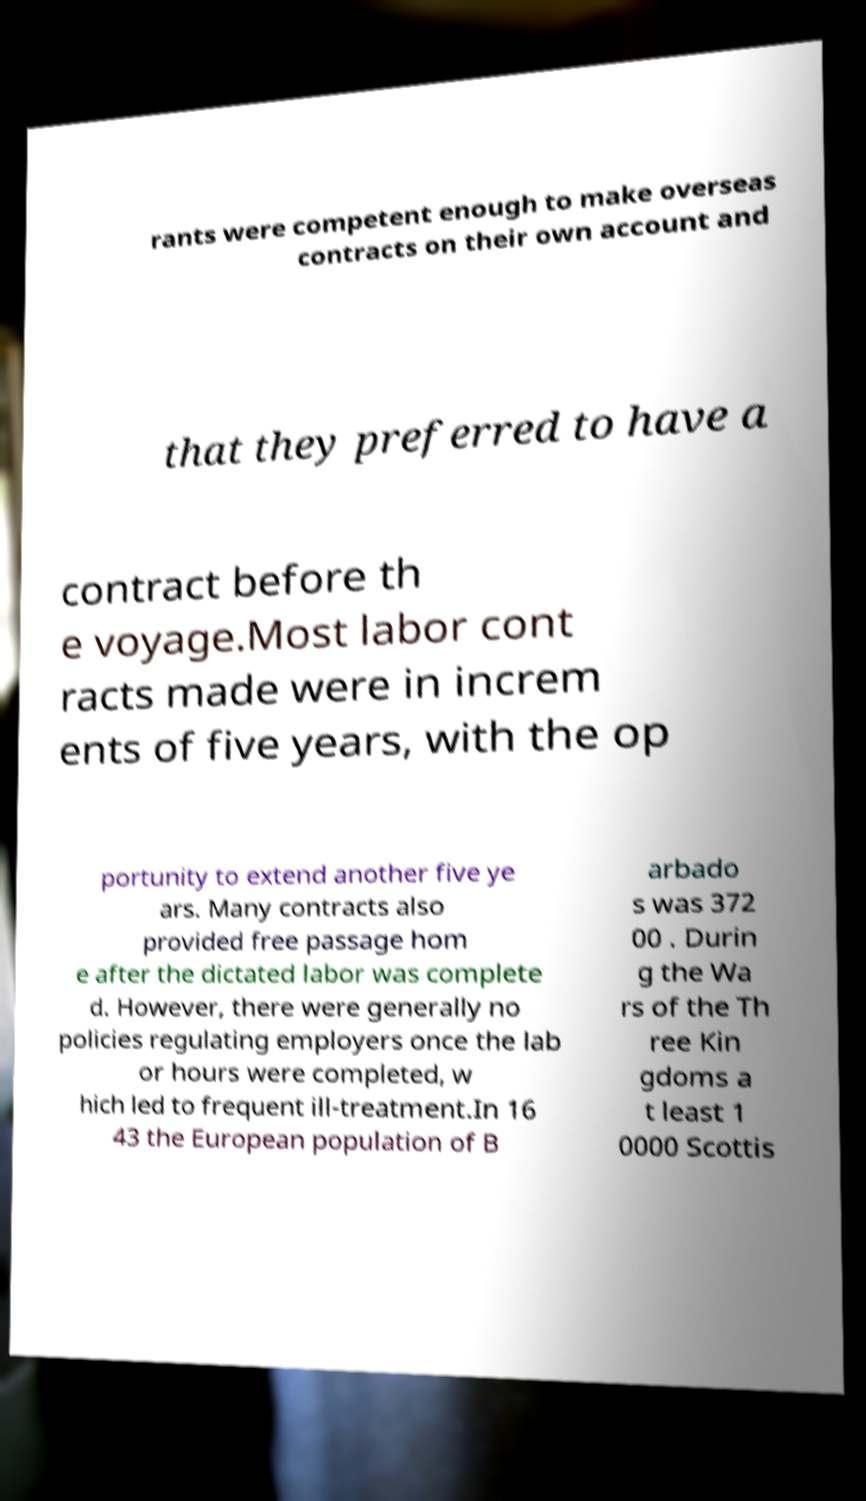Please read and relay the text visible in this image. What does it say? rants were competent enough to make overseas contracts on their own account and that they preferred to have a contract before th e voyage.Most labor cont racts made were in increm ents of five years, with the op portunity to extend another five ye ars. Many contracts also provided free passage hom e after the dictated labor was complete d. However, there were generally no policies regulating employers once the lab or hours were completed, w hich led to frequent ill-treatment.In 16 43 the European population of B arbado s was 372 00 . Durin g the Wa rs of the Th ree Kin gdoms a t least 1 0000 Scottis 